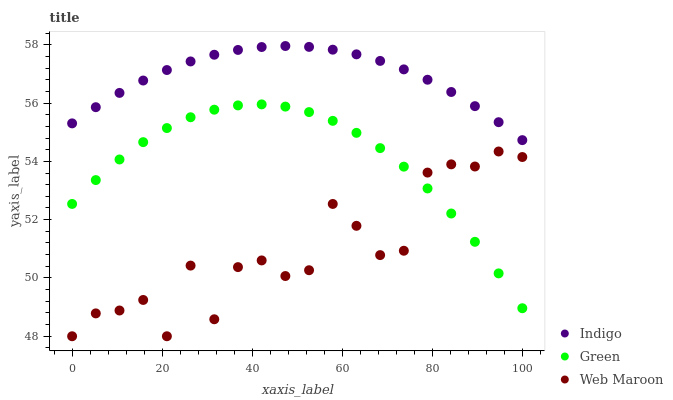Does Web Maroon have the minimum area under the curve?
Answer yes or no. Yes. Does Indigo have the maximum area under the curve?
Answer yes or no. Yes. Does Indigo have the minimum area under the curve?
Answer yes or no. No. Does Web Maroon have the maximum area under the curve?
Answer yes or no. No. Is Indigo the smoothest?
Answer yes or no. Yes. Is Web Maroon the roughest?
Answer yes or no. Yes. Is Web Maroon the smoothest?
Answer yes or no. No. Is Indigo the roughest?
Answer yes or no. No. Does Web Maroon have the lowest value?
Answer yes or no. Yes. Does Indigo have the lowest value?
Answer yes or no. No. Does Indigo have the highest value?
Answer yes or no. Yes. Does Web Maroon have the highest value?
Answer yes or no. No. Is Green less than Indigo?
Answer yes or no. Yes. Is Indigo greater than Green?
Answer yes or no. Yes. Does Web Maroon intersect Green?
Answer yes or no. Yes. Is Web Maroon less than Green?
Answer yes or no. No. Is Web Maroon greater than Green?
Answer yes or no. No. Does Green intersect Indigo?
Answer yes or no. No. 